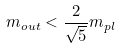<formula> <loc_0><loc_0><loc_500><loc_500>m _ { o u t } < \frac { 2 } { \sqrt { 5 } } m _ { p l }</formula> 